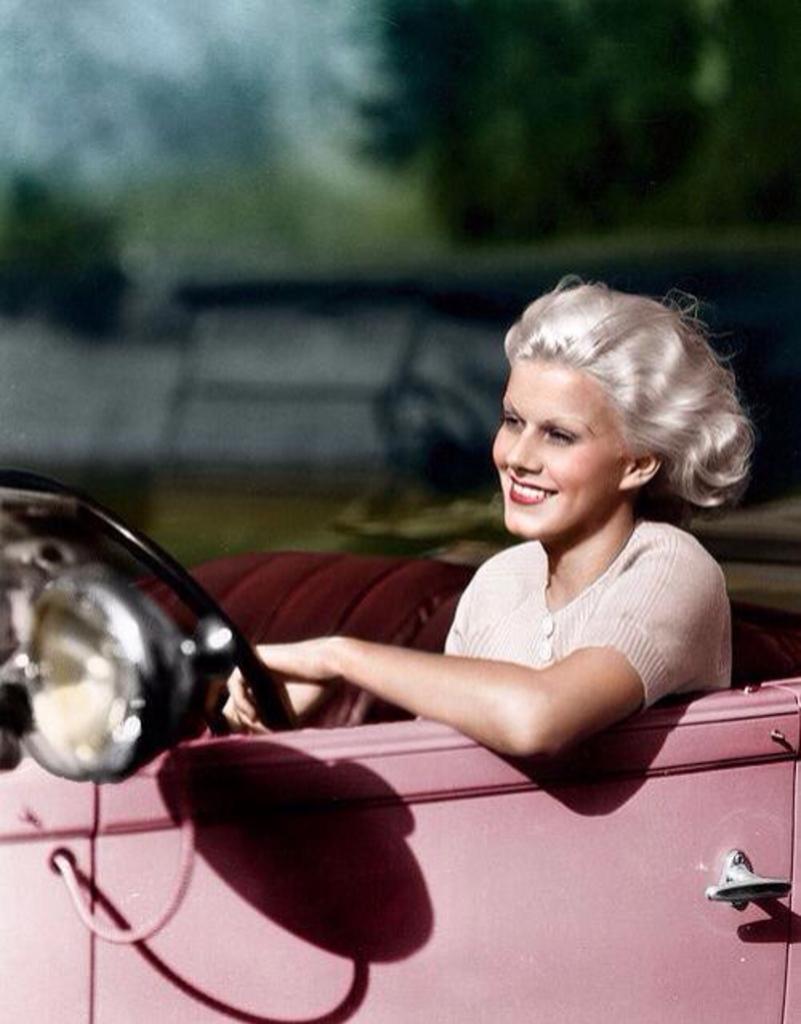Can you describe this image briefly? Here we see woman seated in the car with a smile on her face. 